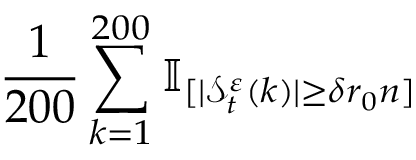<formula> <loc_0><loc_0><loc_500><loc_500>\frac { 1 } { 2 0 0 } \sum _ { k = 1 } ^ { 2 0 0 } \mathbb { I } _ { [ | \mathcal { S } _ { t } ^ { \varepsilon } ( k ) | \geq \delta r _ { 0 } n ] }</formula> 